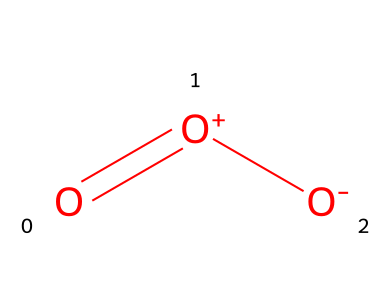What is the name of this oxidizer? This chemical structure corresponds to ozone, a well-known oxidizer that occurs naturally in the atmosphere.
Answer: ozone How many oxygen atoms are present in the structure? The structure shows three oxygen atoms connected in a specific arrangement, identifiable by the presence of three 'O' symbols in the SMILES representation.
Answer: three What type of chemical bond is predominant in ozone? The structure of ozone includes a resonance form where a single bond and a double bond are present between the oxygen atoms, indicating that both bond types are significant in ozone’s stability.
Answer: resonance How many total bonds are represented in the ozone molecule? The visual representation includes one double bond and one single bond, which together lead to two bonds contributing to the overall count.
Answer: two Is ozone an oxidizing agent? Given that ozone has strong oxidizing properties, evidenced by its ability to participate in oxidation reactions, it is classified as an oxidizing agent.
Answer: yes What is the charge on the central oxygen atom in ozone? The structure indicates that the central oxygen is represented with a positive formal charge, which is critical for understanding its reactivity in chemical processes.
Answer: positive What role does ozone play in the atmosphere? Ozone absorbs harmful ultraviolet radiation from the sun, which is essential for protecting living organisms and maintaining ecological balance, a fact derived from its presence in the stratosphere.
Answer: protects 